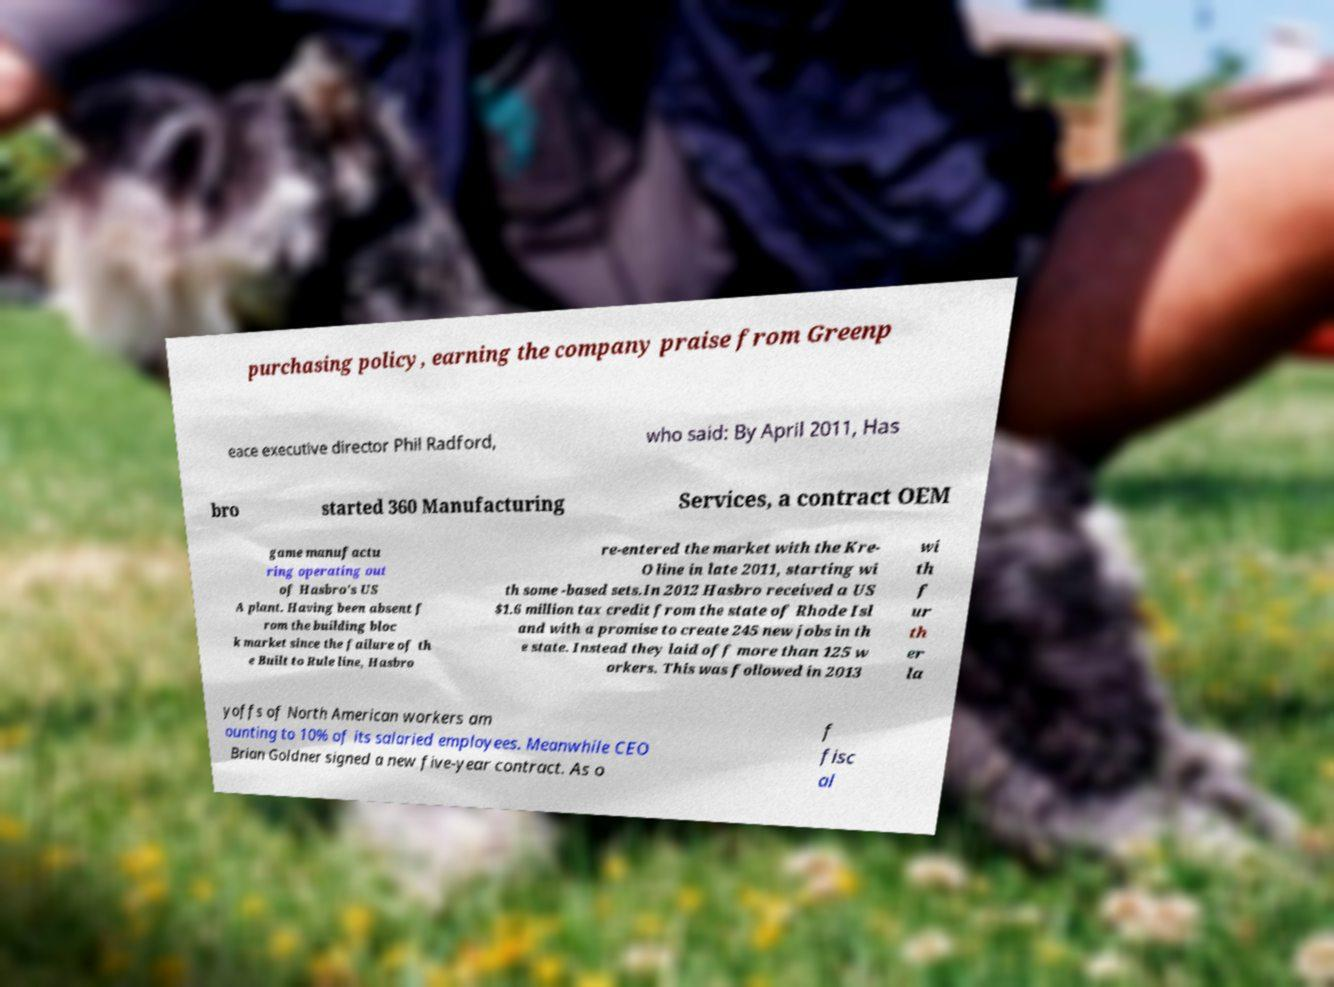I need the written content from this picture converted into text. Can you do that? purchasing policy, earning the company praise from Greenp eace executive director Phil Radford, who said: By April 2011, Has bro started 360 Manufacturing Services, a contract OEM game manufactu ring operating out of Hasbro's US A plant. Having been absent f rom the building bloc k market since the failure of th e Built to Rule line, Hasbro re-entered the market with the Kre- O line in late 2011, starting wi th some -based sets.In 2012 Hasbro received a US $1.6 million tax credit from the state of Rhode Isl and with a promise to create 245 new jobs in th e state. Instead they laid off more than 125 w orkers. This was followed in 2013 wi th f ur th er la yoffs of North American workers am ounting to 10% of its salaried employees. Meanwhile CEO Brian Goldner signed a new five-year contract. As o f fisc al 